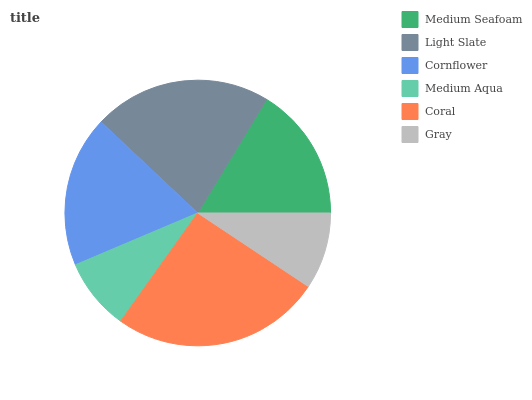Is Medium Aqua the minimum?
Answer yes or no. Yes. Is Coral the maximum?
Answer yes or no. Yes. Is Light Slate the minimum?
Answer yes or no. No. Is Light Slate the maximum?
Answer yes or no. No. Is Light Slate greater than Medium Seafoam?
Answer yes or no. Yes. Is Medium Seafoam less than Light Slate?
Answer yes or no. Yes. Is Medium Seafoam greater than Light Slate?
Answer yes or no. No. Is Light Slate less than Medium Seafoam?
Answer yes or no. No. Is Cornflower the high median?
Answer yes or no. Yes. Is Medium Seafoam the low median?
Answer yes or no. Yes. Is Medium Seafoam the high median?
Answer yes or no. No. Is Gray the low median?
Answer yes or no. No. 